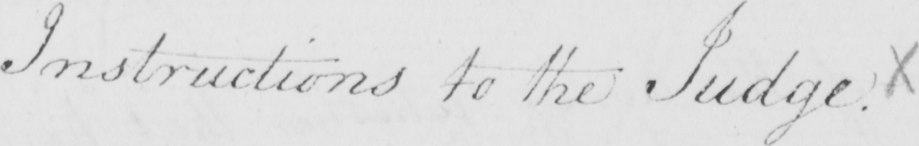Can you tell me what this handwritten text says? Instructions to the Judge . X 